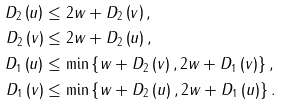Convert formula to latex. <formula><loc_0><loc_0><loc_500><loc_500>D _ { 2 } \left ( u \right ) & \leq 2 w + D _ { 2 } \left ( v \right ) , \\ D _ { 2 } \left ( v \right ) & \leq 2 w + D _ { 2 } \left ( u \right ) , \\ D _ { 1 } \left ( u \right ) & \leq \min \left \{ w + D _ { 2 } \left ( v \right ) , 2 w + D _ { 1 } \left ( v \right ) \right \} , \\ D _ { 1 } \left ( v \right ) & \leq \min \left \{ w + D _ { 2 } \left ( u \right ) , 2 w + D _ { 1 } \left ( u \right ) \right \} .</formula> 